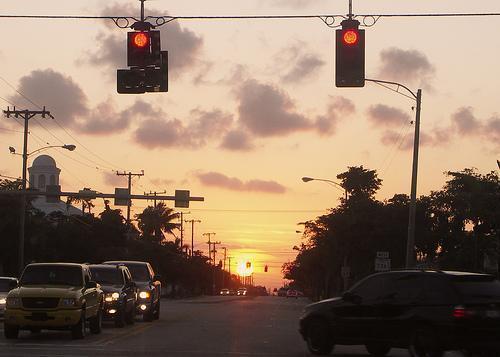How many red lights are there?
Give a very brief answer. 2. 